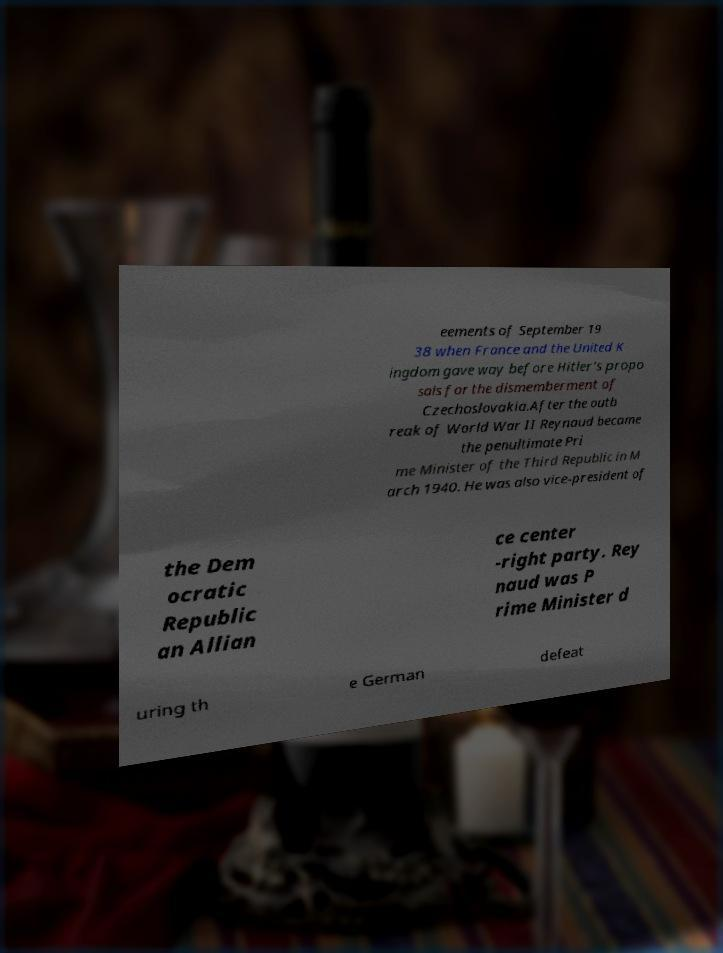Can you accurately transcribe the text from the provided image for me? eements of September 19 38 when France and the United K ingdom gave way before Hitler's propo sals for the dismemberment of Czechoslovakia.After the outb reak of World War II Reynaud became the penultimate Pri me Minister of the Third Republic in M arch 1940. He was also vice-president of the Dem ocratic Republic an Allian ce center -right party. Rey naud was P rime Minister d uring th e German defeat 